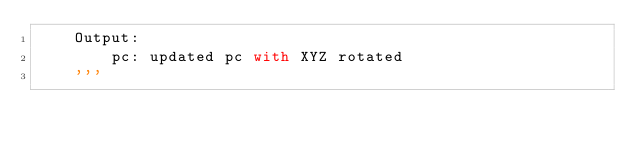Convert code to text. <code><loc_0><loc_0><loc_500><loc_500><_Python_>    Output:
        pc: updated pc with XYZ rotated
    '''</code> 